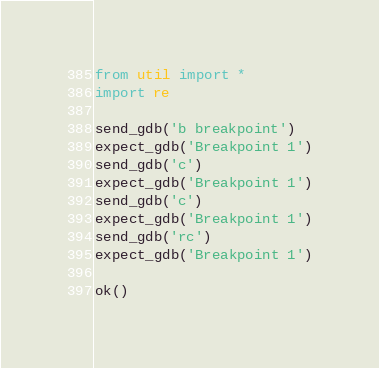Convert code to text. <code><loc_0><loc_0><loc_500><loc_500><_Python_>from util import *
import re

send_gdb('b breakpoint')
expect_gdb('Breakpoint 1')
send_gdb('c')
expect_gdb('Breakpoint 1')
send_gdb('c')
expect_gdb('Breakpoint 1')
send_gdb('rc')
expect_gdb('Breakpoint 1')

ok()
</code> 